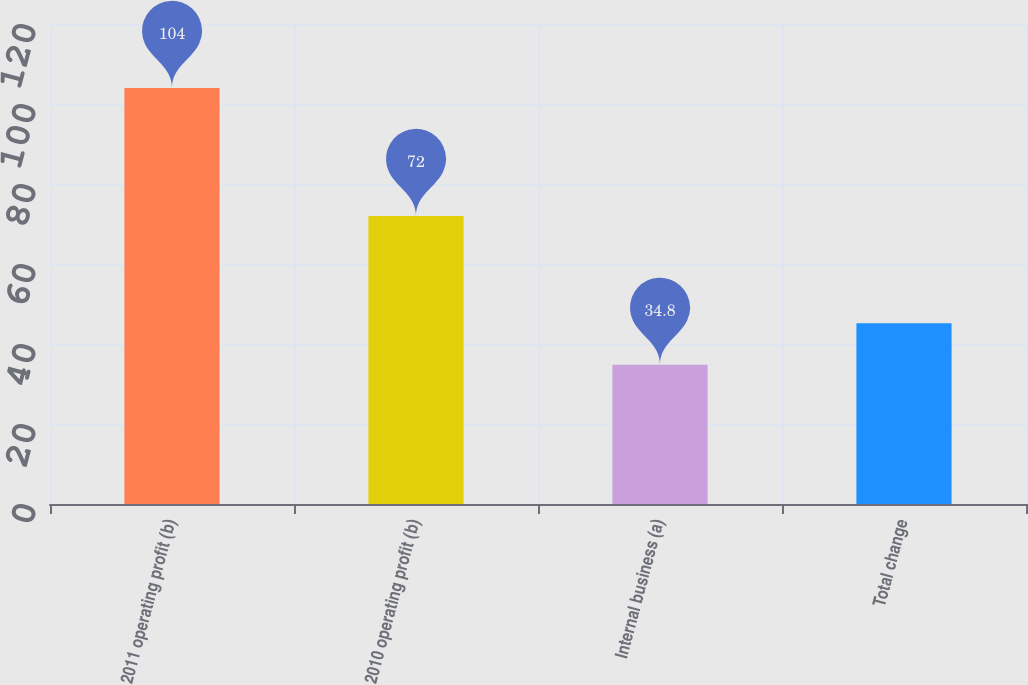<chart> <loc_0><loc_0><loc_500><loc_500><bar_chart><fcel>2011 operating profit (b)<fcel>2010 operating profit (b)<fcel>Internal business (a)<fcel>Total change<nl><fcel>104<fcel>72<fcel>34.8<fcel>45.2<nl></chart> 